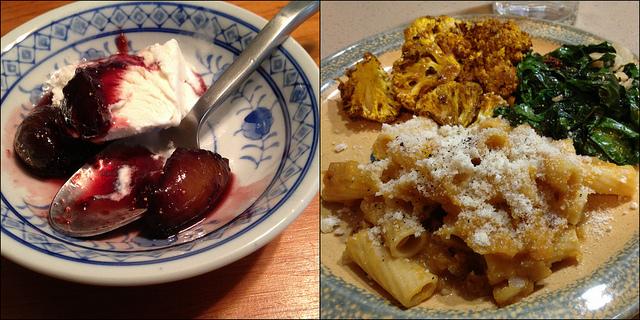Is the dinner consisting of pasta?
Concise answer only. Yes. What is on the left?
Keep it brief. Ice cream. Is there dessert?
Be succinct. Yes. 